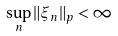Convert formula to latex. <formula><loc_0><loc_0><loc_500><loc_500>\sup _ { n } \| \xi _ { n } \| _ { p } < \infty</formula> 